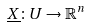Convert formula to latex. <formula><loc_0><loc_0><loc_500><loc_500>\underline { X } \colon U \rightarrow \mathbb { R } ^ { n }</formula> 